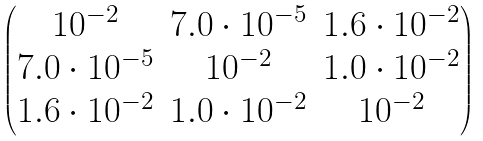Convert formula to latex. <formula><loc_0><loc_0><loc_500><loc_500>\begin{pmatrix} 1 0 ^ { - 2 } & 7 . 0 \cdot 1 0 ^ { - 5 } & 1 . 6 \cdot 1 0 ^ { - 2 } \\ 7 . 0 \cdot 1 0 ^ { - 5 } & 1 0 ^ { - 2 } & 1 . 0 \cdot 1 0 ^ { - 2 } \\ 1 . 6 \cdot 1 0 ^ { - 2 } & 1 . 0 \cdot 1 0 ^ { - 2 } & 1 0 ^ { - 2 } \end{pmatrix}</formula> 